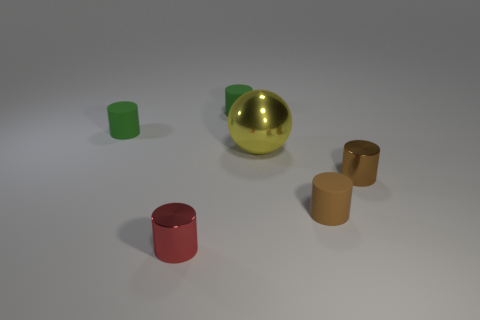Subtract all tiny brown cylinders. How many cylinders are left? 3 Subtract all brown balls. How many green cylinders are left? 2 Subtract all brown cylinders. How many cylinders are left? 3 Subtract 1 cylinders. How many cylinders are left? 4 Add 1 green matte spheres. How many objects exist? 7 Subtract all spheres. How many objects are left? 5 Subtract all purple cylinders. Subtract all green spheres. How many cylinders are left? 5 Subtract all large yellow metal things. Subtract all metal spheres. How many objects are left? 4 Add 2 green cylinders. How many green cylinders are left? 4 Add 5 matte cylinders. How many matte cylinders exist? 8 